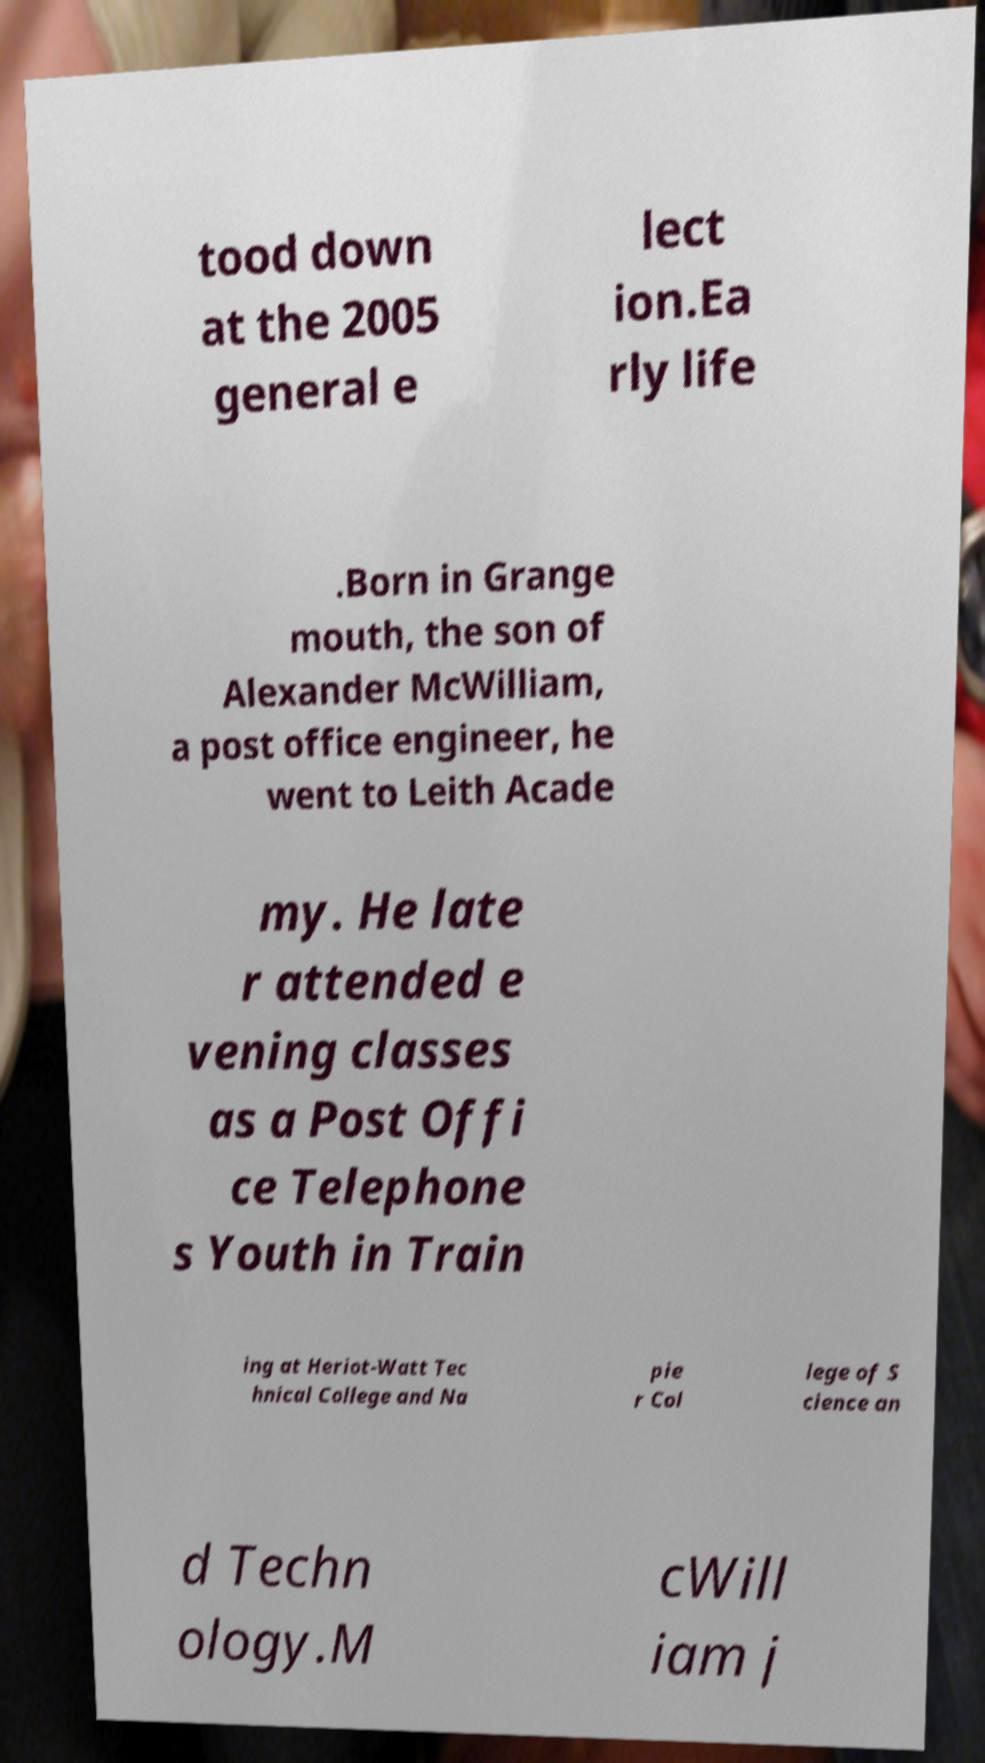I need the written content from this picture converted into text. Can you do that? tood down at the 2005 general e lect ion.Ea rly life .Born in Grange mouth, the son of Alexander McWilliam, a post office engineer, he went to Leith Acade my. He late r attended e vening classes as a Post Offi ce Telephone s Youth in Train ing at Heriot-Watt Tec hnical College and Na pie r Col lege of S cience an d Techn ology.M cWill iam j 